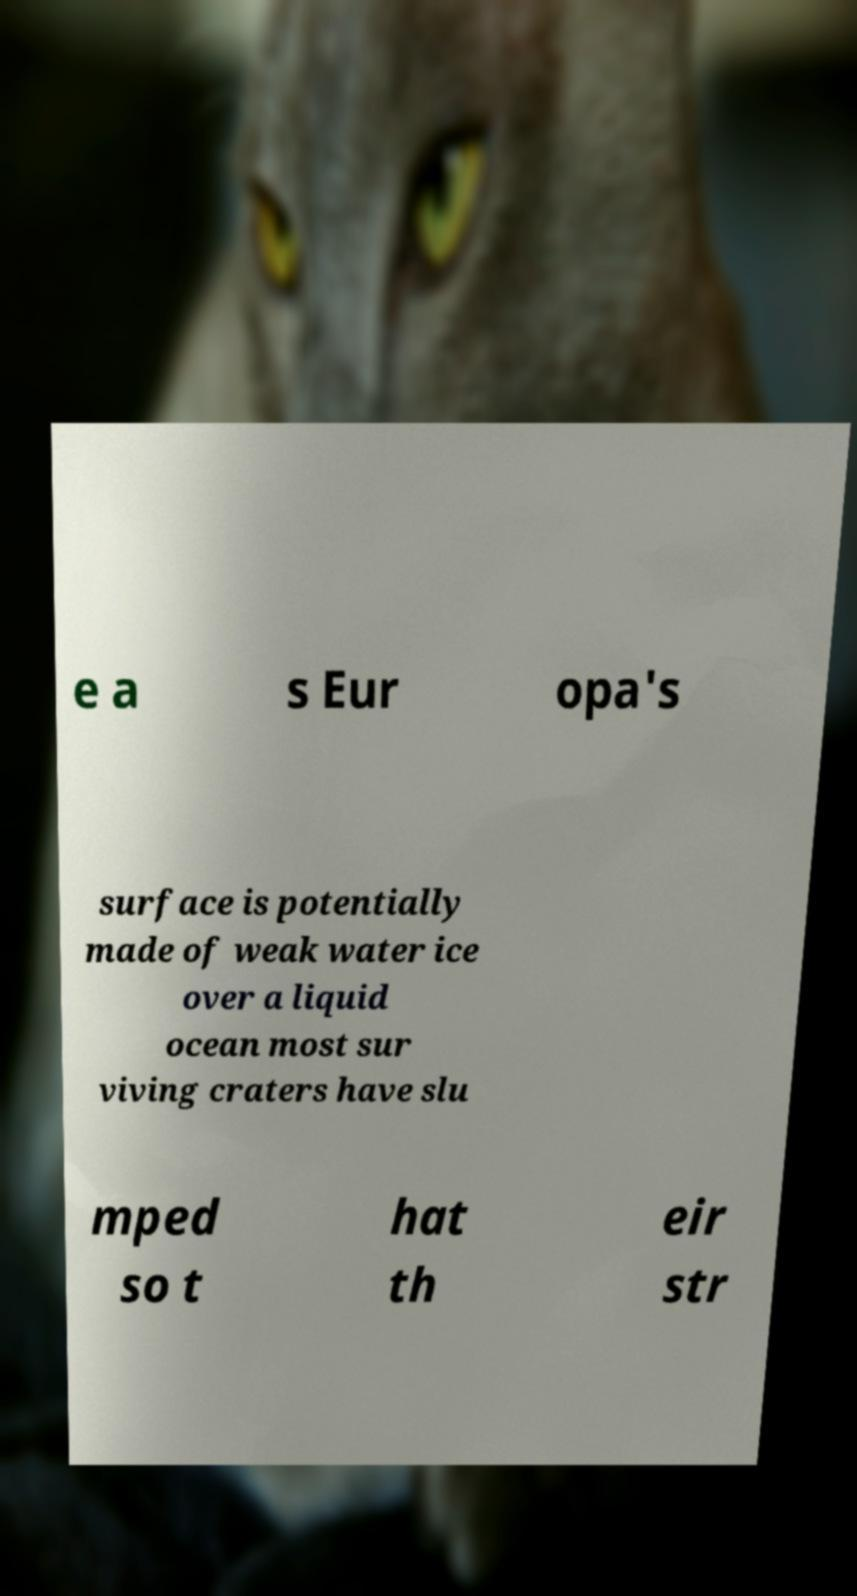Could you extract and type out the text from this image? e a s Eur opa's surface is potentially made of weak water ice over a liquid ocean most sur viving craters have slu mped so t hat th eir str 